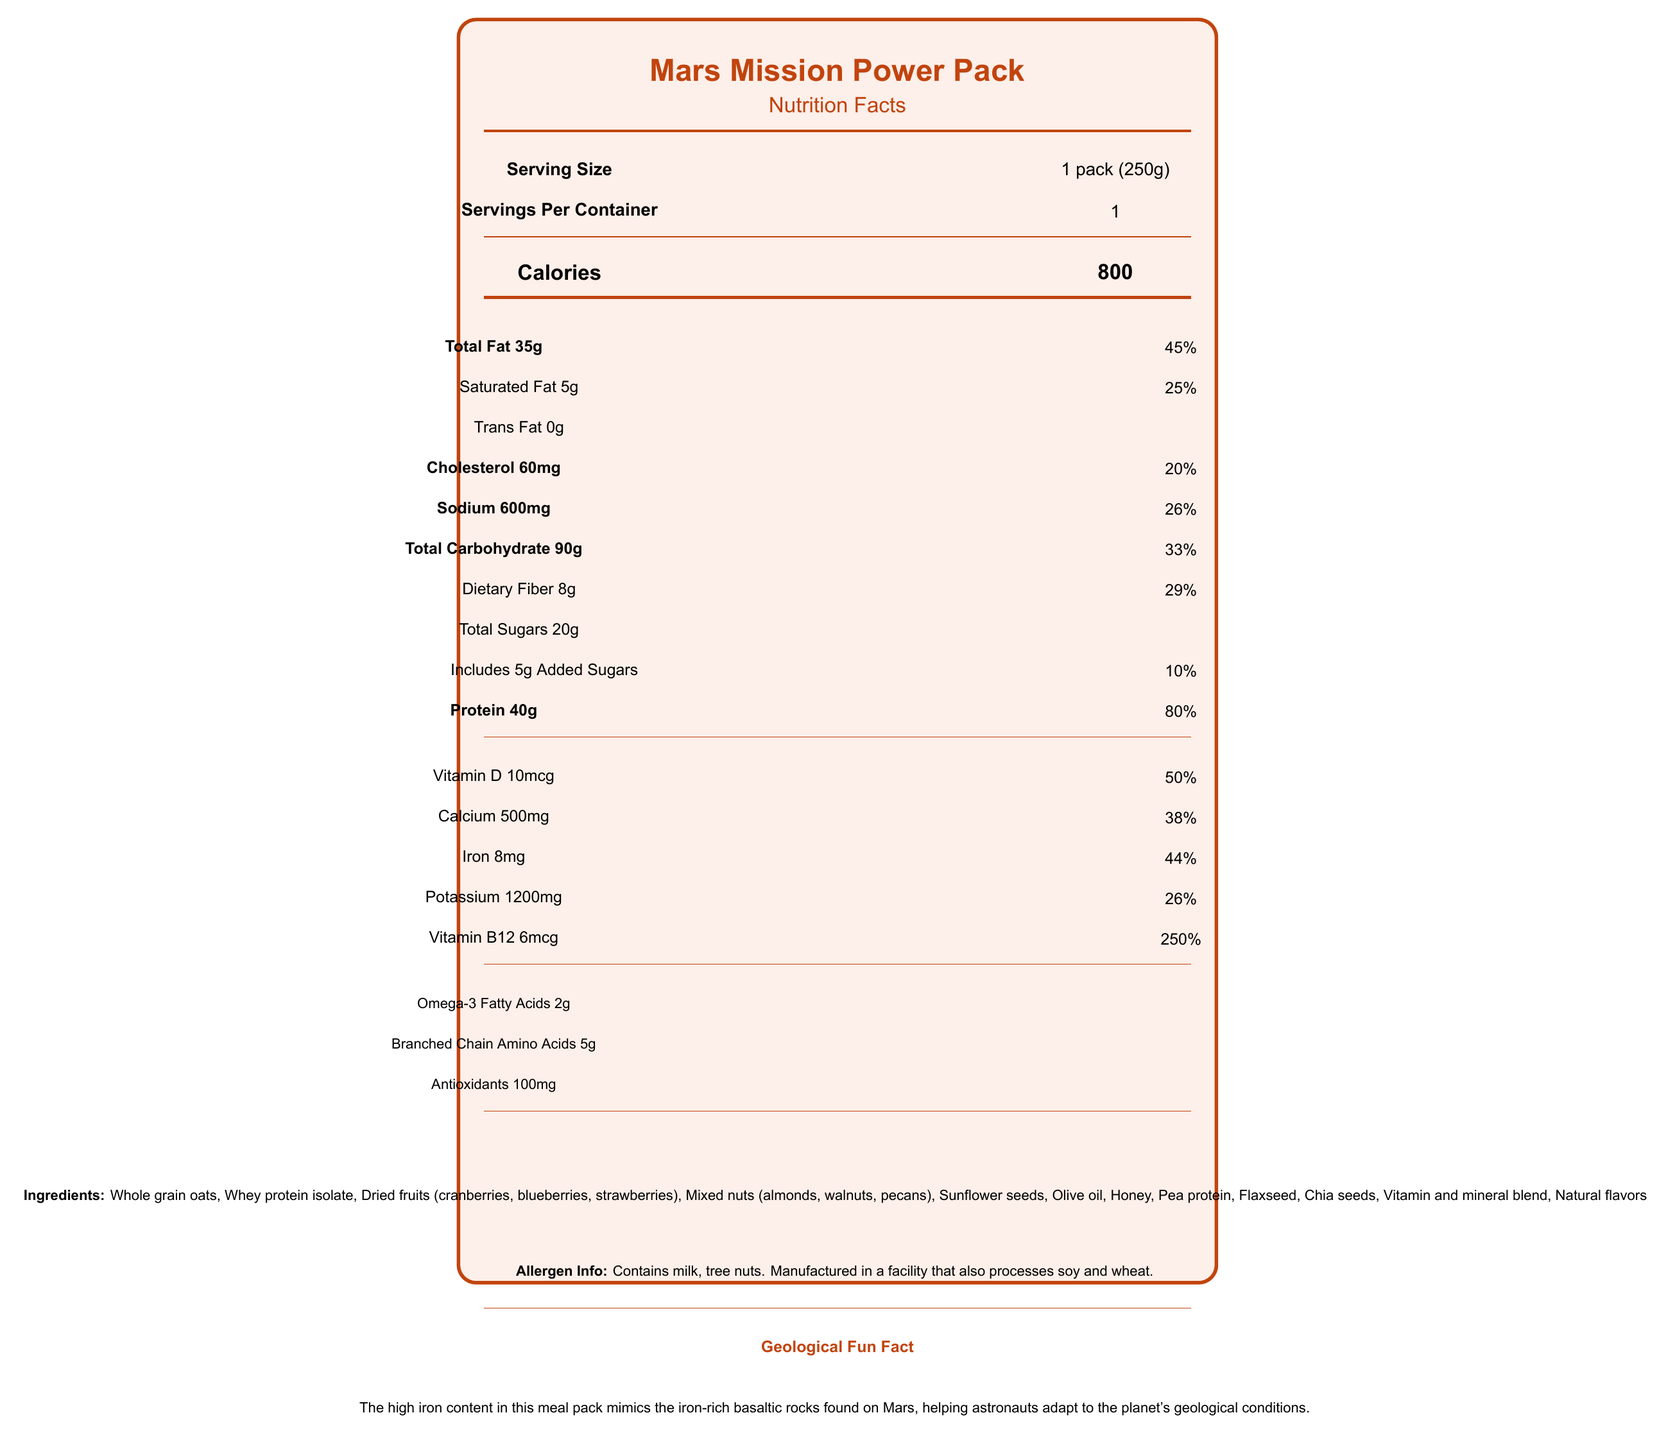What is the product name? The product name is clearly stated at the top of the document.
Answer: Mars Mission Power Pack What is the serving size for Mars Mission Power Pack? The serving size is listed as 1 pack, which weighs 250 grams.
Answer: 1 pack (250g) How many calories are there per serving? This information is prominently displayed under the "Calories" section.
Answer: 800 calories How much protein does one serving contain? The amount of protein is provided under the "Protein" section, which lists 40 grams with an 80% daily value.
Answer: 40g Which vitamin has the highest daily value percentage in this meal? A. Vitamin D B. Calcium C. Iron D. Vitamin B12 Vitamin B12 has the highest daily value percentage at 250%, as shown under the vitamins and minerals section.
Answer: D. Vitamin B12 How much total fat is in one serving of Mars Mission Power Pack? The total fat amount is listed under the "Total Fat" section as 35 grams.
Answer: 35g How many grams of dietary fiber are in a single pack? The dietary fiber amount is listed under "Dietary Fiber," which is 8 grams per serving.
Answer: 8g What are the main ingredients in this meal pack? The list of ingredients is provided in the ingredients section of the document.
Answer: Whole grain oats, Whey protein isolate, Dried fruits (cranberries, blueberries, strawberries), Mixed nuts (almonds, walnuts, pecans), Sunflower seeds, Olive oil, Honey, Pea protein, Flaxseed, Chia seeds, Vitamin and mineral blend, Natural flavors What is the daily value percentage for calcium in this meal? The daily value percentage for calcium is given under the "Calcium" section, which is 38%.
Answer: 38% How much potassium is in one serving of Mars Mission Power Pack? The amount of potassium is listed under "Potassium" as 1200 milligrams.
Answer: 1200mg Which nutrient has the lowest daily value percentage? A. Sodium B. Cholesterol C. Added Sugars D. Saturated Fat Cholesterol has a daily value of 20%, which is the lowest listed in the document.
Answer: B. Cholesterol Does the Mars Mission Power Pack contain any added sugars? The document mentions that it includes 5 grams of added sugars.
Answer: Yes Is the Mars Mission Power Pack suitable for people with nut allergies? The allergen information clearly states that it contains tree nuts and milk, making it unsuitable for individuals with nut allergies.
Answer: No What makes this meal pack geologically interesting for a Mars mission? The geological fun fact section details that the high iron content in the meal pack mimics Mars' geology, helping astronauts adapt to Martian conditions.
Answer: Its high iron content mimics the iron-rich basaltic rocks found on Mars. Can the Mars Mission Power Pack be stored in a refrigerator? The storage instructions suggest storing in a cool, dry place, but they don't specify if refrigeration is acceptable.
Answer: Not enough information Summarize the nutritional and practical highlights of the Mars Mission Power Pack. This summary captures the key nutritional components, ingredients, and practical details like storage instructions and allergen information, along with its geological significance for Mars missions.
Answer: The Mars Mission Power Pack is a nutrient-dense meal designed for astronaut physical training, offering 800 calories per serving with 40g of protein. It includes essential vitamins and minerals, including 250% daily value of Vitamin B12. The meal pack contains whole grains, whey protein, dried fruits, mixed nuts, and seeds. It also has a high iron content to mimic Martian rocks, aiding astronauts' adaptation. Storage instructions and allergen info are also provided. 